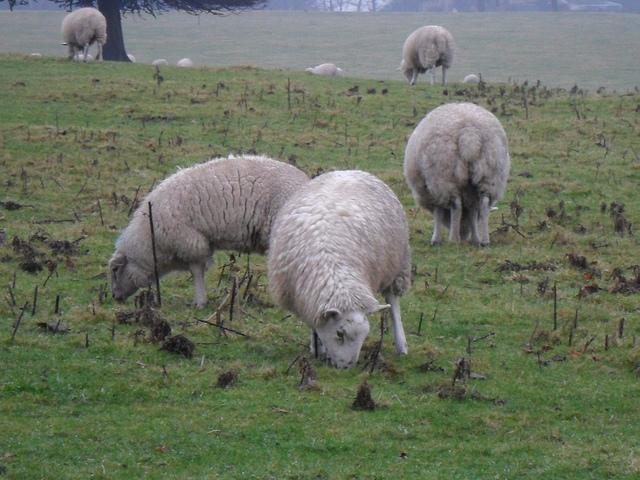How many animals are in the picture?
Give a very brief answer. 5. How many sheep are there?
Give a very brief answer. 5. 